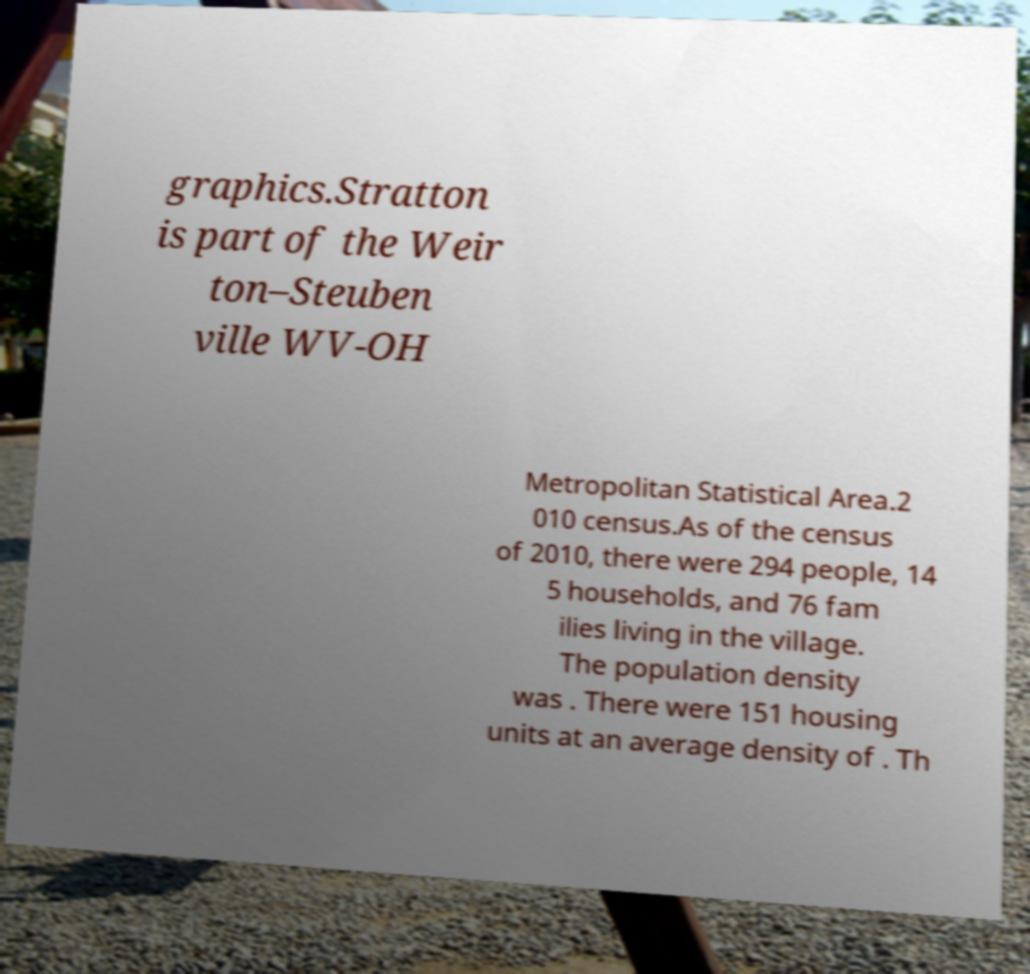What messages or text are displayed in this image? I need them in a readable, typed format. graphics.Stratton is part of the Weir ton–Steuben ville WV-OH Metropolitan Statistical Area.2 010 census.As of the census of 2010, there were 294 people, 14 5 households, and 76 fam ilies living in the village. The population density was . There were 151 housing units at an average density of . Th 